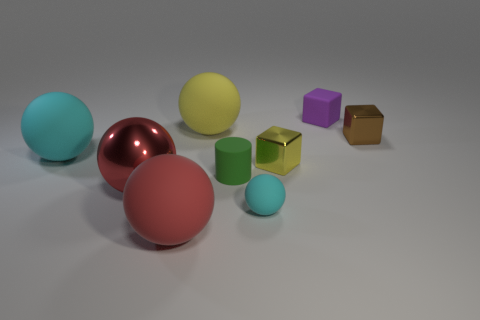Subtract 1 balls. How many balls are left? 4 Subtract all yellow balls. How many balls are left? 4 Subtract all rubber spheres. How many spheres are left? 1 Add 1 small yellow things. How many objects exist? 10 Subtract all yellow balls. Subtract all blue blocks. How many balls are left? 4 Subtract all cylinders. How many objects are left? 8 Subtract 0 gray cylinders. How many objects are left? 9 Subtract all metal cubes. Subtract all shiny cubes. How many objects are left? 5 Add 4 purple things. How many purple things are left? 5 Add 1 tiny purple cubes. How many tiny purple cubes exist? 2 